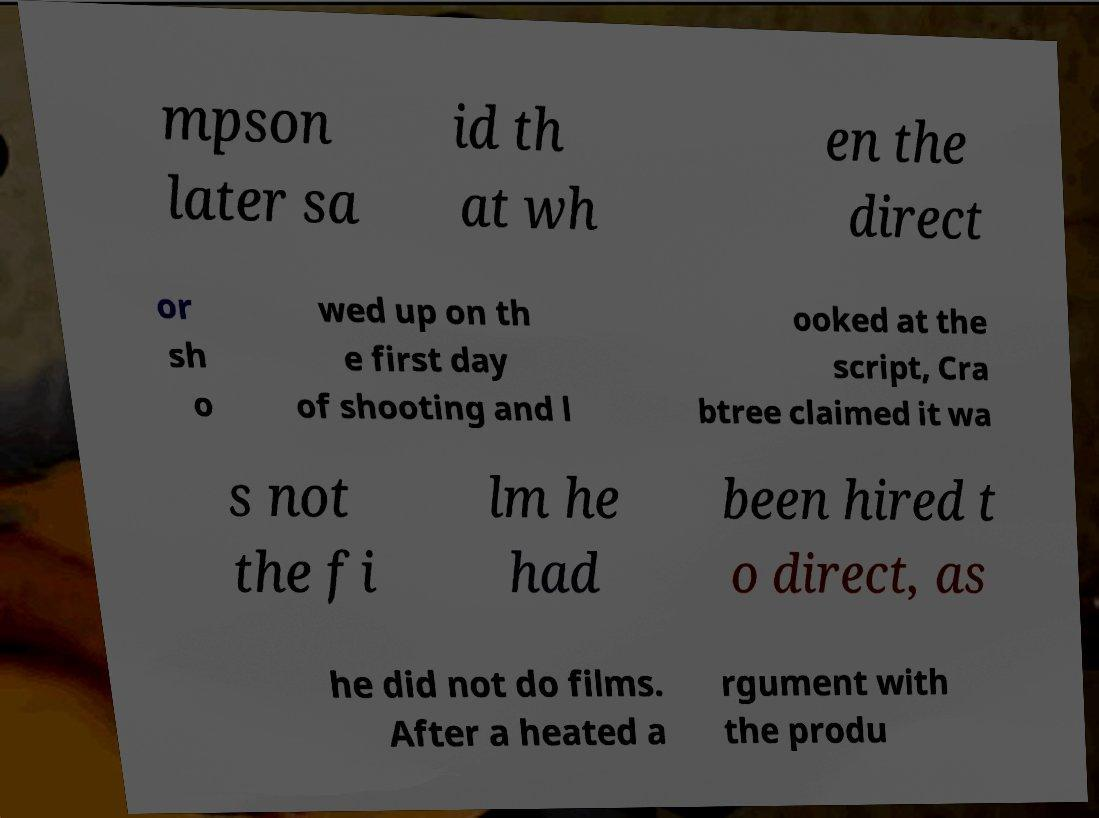For documentation purposes, I need the text within this image transcribed. Could you provide that? mpson later sa id th at wh en the direct or sh o wed up on th e first day of shooting and l ooked at the script, Cra btree claimed it wa s not the fi lm he had been hired t o direct, as he did not do films. After a heated a rgument with the produ 